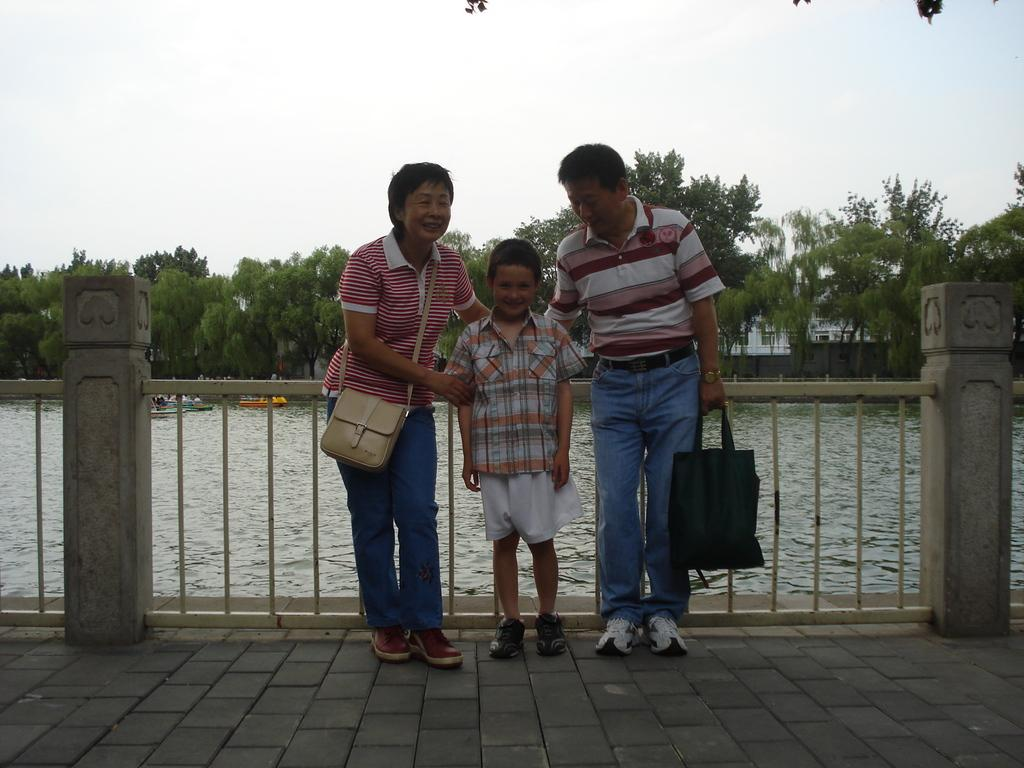How many people can be seen in the image? There are people standing in the image. What are the people holding or carrying? One person is holding a bag, and another person is carrying a bag. What can be seen in the background of the image? In the background, there are boats above the water, trees, a building, a wall, and the sky. What is the purpose of the fence in the image? The purpose of the fence is not specified in the image, but it could be for separating or enclosing an area. What type of lip balm is the person applying in the image? There is no lip balm or person applying it in the image; it features people standing near a fence with a background of boats, trees, a building, a wall, and the sky. 